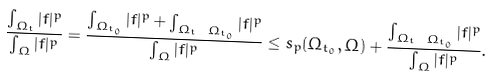Convert formula to latex. <formula><loc_0><loc_0><loc_500><loc_500>\frac { \int _ { \Omega _ { t } } | f | ^ { p } } { \int _ { \Omega } | f | ^ { p } } = \frac { \int _ { \Omega _ { t _ { 0 } } } | f | ^ { p } + \int _ { \Omega _ { t } \ \Omega _ { t _ { 0 } } } | f | ^ { p } } { \int _ { \Omega } | f | ^ { p } } \leq { s _ { p } ( \Omega _ { t _ { 0 } } , \Omega ) } + \frac { \int _ { \Omega _ { t } \ \Omega _ { t _ { 0 } } } | f | ^ { p } } { \int _ { \Omega } | f | ^ { p } } .</formula> 